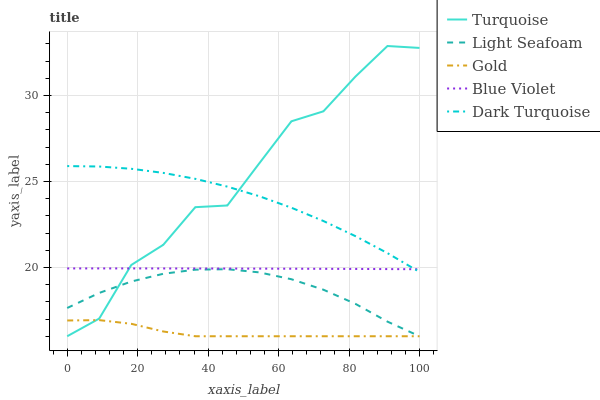Does Gold have the minimum area under the curve?
Answer yes or no. Yes. Does Turquoise have the maximum area under the curve?
Answer yes or no. Yes. Does Light Seafoam have the minimum area under the curve?
Answer yes or no. No. Does Light Seafoam have the maximum area under the curve?
Answer yes or no. No. Is Blue Violet the smoothest?
Answer yes or no. Yes. Is Turquoise the roughest?
Answer yes or no. Yes. Is Light Seafoam the smoothest?
Answer yes or no. No. Is Light Seafoam the roughest?
Answer yes or no. No. Does Blue Violet have the lowest value?
Answer yes or no. No. Does Turquoise have the highest value?
Answer yes or no. Yes. Does Light Seafoam have the highest value?
Answer yes or no. No. Is Light Seafoam less than Blue Violet?
Answer yes or no. Yes. Is Dark Turquoise greater than Gold?
Answer yes or no. Yes. Does Turquoise intersect Light Seafoam?
Answer yes or no. Yes. Is Turquoise less than Light Seafoam?
Answer yes or no. No. Is Turquoise greater than Light Seafoam?
Answer yes or no. No. Does Light Seafoam intersect Blue Violet?
Answer yes or no. No. 